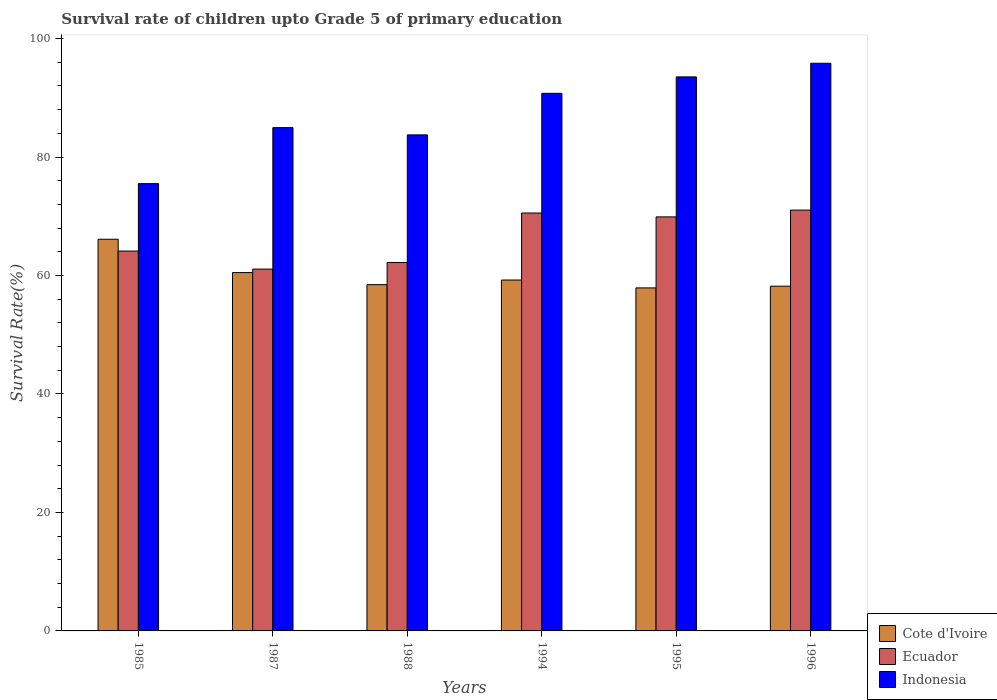How many groups of bars are there?
Your answer should be very brief. 6. How many bars are there on the 5th tick from the left?
Give a very brief answer. 3. How many bars are there on the 6th tick from the right?
Give a very brief answer. 3. What is the label of the 1st group of bars from the left?
Give a very brief answer. 1985. In how many cases, is the number of bars for a given year not equal to the number of legend labels?
Your answer should be very brief. 0. What is the survival rate of children in Cote d'Ivoire in 1996?
Make the answer very short. 58.19. Across all years, what is the maximum survival rate of children in Ecuador?
Offer a very short reply. 71.04. Across all years, what is the minimum survival rate of children in Cote d'Ivoire?
Offer a very short reply. 57.91. In which year was the survival rate of children in Indonesia minimum?
Your answer should be very brief. 1985. What is the total survival rate of children in Cote d'Ivoire in the graph?
Provide a short and direct response. 360.4. What is the difference between the survival rate of children in Cote d'Ivoire in 1985 and that in 1995?
Provide a succinct answer. 8.21. What is the difference between the survival rate of children in Ecuador in 1988 and the survival rate of children in Cote d'Ivoire in 1995?
Make the answer very short. 4.29. What is the average survival rate of children in Ecuador per year?
Your response must be concise. 66.48. In the year 1995, what is the difference between the survival rate of children in Ecuador and survival rate of children in Cote d'Ivoire?
Keep it short and to the point. 11.99. What is the ratio of the survival rate of children in Ecuador in 1994 to that in 1995?
Keep it short and to the point. 1.01. Is the survival rate of children in Ecuador in 1987 less than that in 1988?
Your response must be concise. Yes. What is the difference between the highest and the second highest survival rate of children in Cote d'Ivoire?
Keep it short and to the point. 5.63. What is the difference between the highest and the lowest survival rate of children in Cote d'Ivoire?
Give a very brief answer. 8.21. Is the sum of the survival rate of children in Indonesia in 1985 and 1988 greater than the maximum survival rate of children in Cote d'Ivoire across all years?
Provide a short and direct response. Yes. What does the 1st bar from the left in 1995 represents?
Offer a very short reply. Cote d'Ivoire. What does the 3rd bar from the right in 1988 represents?
Your answer should be compact. Cote d'Ivoire. What is the difference between two consecutive major ticks on the Y-axis?
Keep it short and to the point. 20. Where does the legend appear in the graph?
Ensure brevity in your answer.  Bottom right. How many legend labels are there?
Your response must be concise. 3. How are the legend labels stacked?
Offer a very short reply. Vertical. What is the title of the graph?
Provide a short and direct response. Survival rate of children upto Grade 5 of primary education. What is the label or title of the X-axis?
Ensure brevity in your answer.  Years. What is the label or title of the Y-axis?
Give a very brief answer. Survival Rate(%). What is the Survival Rate(%) of Cote d'Ivoire in 1985?
Your answer should be very brief. 66.12. What is the Survival Rate(%) of Ecuador in 1985?
Give a very brief answer. 64.13. What is the Survival Rate(%) in Indonesia in 1985?
Your answer should be compact. 75.51. What is the Survival Rate(%) of Cote d'Ivoire in 1987?
Provide a succinct answer. 60.49. What is the Survival Rate(%) of Ecuador in 1987?
Provide a short and direct response. 61.08. What is the Survival Rate(%) in Indonesia in 1987?
Make the answer very short. 84.96. What is the Survival Rate(%) in Cote d'Ivoire in 1988?
Make the answer very short. 58.46. What is the Survival Rate(%) of Ecuador in 1988?
Make the answer very short. 62.2. What is the Survival Rate(%) in Indonesia in 1988?
Offer a terse response. 83.74. What is the Survival Rate(%) of Cote d'Ivoire in 1994?
Offer a terse response. 59.23. What is the Survival Rate(%) in Ecuador in 1994?
Give a very brief answer. 70.55. What is the Survival Rate(%) of Indonesia in 1994?
Your answer should be very brief. 90.75. What is the Survival Rate(%) of Cote d'Ivoire in 1995?
Offer a terse response. 57.91. What is the Survival Rate(%) in Ecuador in 1995?
Keep it short and to the point. 69.89. What is the Survival Rate(%) in Indonesia in 1995?
Provide a short and direct response. 93.52. What is the Survival Rate(%) in Cote d'Ivoire in 1996?
Your response must be concise. 58.19. What is the Survival Rate(%) of Ecuador in 1996?
Your answer should be compact. 71.04. What is the Survival Rate(%) of Indonesia in 1996?
Keep it short and to the point. 95.83. Across all years, what is the maximum Survival Rate(%) in Cote d'Ivoire?
Give a very brief answer. 66.12. Across all years, what is the maximum Survival Rate(%) in Ecuador?
Your response must be concise. 71.04. Across all years, what is the maximum Survival Rate(%) of Indonesia?
Your answer should be compact. 95.83. Across all years, what is the minimum Survival Rate(%) of Cote d'Ivoire?
Your answer should be very brief. 57.91. Across all years, what is the minimum Survival Rate(%) of Ecuador?
Your answer should be compact. 61.08. Across all years, what is the minimum Survival Rate(%) in Indonesia?
Your answer should be very brief. 75.51. What is the total Survival Rate(%) in Cote d'Ivoire in the graph?
Your response must be concise. 360.4. What is the total Survival Rate(%) in Ecuador in the graph?
Your answer should be very brief. 398.88. What is the total Survival Rate(%) of Indonesia in the graph?
Your response must be concise. 524.31. What is the difference between the Survival Rate(%) in Cote d'Ivoire in 1985 and that in 1987?
Your response must be concise. 5.63. What is the difference between the Survival Rate(%) in Ecuador in 1985 and that in 1987?
Offer a terse response. 3.04. What is the difference between the Survival Rate(%) of Indonesia in 1985 and that in 1987?
Your answer should be compact. -9.45. What is the difference between the Survival Rate(%) of Cote d'Ivoire in 1985 and that in 1988?
Give a very brief answer. 7.66. What is the difference between the Survival Rate(%) in Ecuador in 1985 and that in 1988?
Make the answer very short. 1.93. What is the difference between the Survival Rate(%) in Indonesia in 1985 and that in 1988?
Offer a very short reply. -8.23. What is the difference between the Survival Rate(%) in Cote d'Ivoire in 1985 and that in 1994?
Offer a very short reply. 6.89. What is the difference between the Survival Rate(%) of Ecuador in 1985 and that in 1994?
Offer a very short reply. -6.42. What is the difference between the Survival Rate(%) of Indonesia in 1985 and that in 1994?
Keep it short and to the point. -15.24. What is the difference between the Survival Rate(%) in Cote d'Ivoire in 1985 and that in 1995?
Offer a very short reply. 8.21. What is the difference between the Survival Rate(%) in Ecuador in 1985 and that in 1995?
Your response must be concise. -5.77. What is the difference between the Survival Rate(%) of Indonesia in 1985 and that in 1995?
Provide a short and direct response. -18.02. What is the difference between the Survival Rate(%) of Cote d'Ivoire in 1985 and that in 1996?
Provide a succinct answer. 7.92. What is the difference between the Survival Rate(%) of Ecuador in 1985 and that in 1996?
Offer a terse response. -6.91. What is the difference between the Survival Rate(%) of Indonesia in 1985 and that in 1996?
Offer a terse response. -20.32. What is the difference between the Survival Rate(%) in Cote d'Ivoire in 1987 and that in 1988?
Provide a short and direct response. 2.03. What is the difference between the Survival Rate(%) in Ecuador in 1987 and that in 1988?
Your response must be concise. -1.11. What is the difference between the Survival Rate(%) in Indonesia in 1987 and that in 1988?
Your answer should be very brief. 1.22. What is the difference between the Survival Rate(%) of Cote d'Ivoire in 1987 and that in 1994?
Offer a terse response. 1.26. What is the difference between the Survival Rate(%) of Ecuador in 1987 and that in 1994?
Your response must be concise. -9.47. What is the difference between the Survival Rate(%) of Indonesia in 1987 and that in 1994?
Provide a succinct answer. -5.79. What is the difference between the Survival Rate(%) in Cote d'Ivoire in 1987 and that in 1995?
Keep it short and to the point. 2.59. What is the difference between the Survival Rate(%) in Ecuador in 1987 and that in 1995?
Offer a very short reply. -8.81. What is the difference between the Survival Rate(%) of Indonesia in 1987 and that in 1995?
Give a very brief answer. -8.56. What is the difference between the Survival Rate(%) of Cote d'Ivoire in 1987 and that in 1996?
Provide a short and direct response. 2.3. What is the difference between the Survival Rate(%) in Ecuador in 1987 and that in 1996?
Provide a succinct answer. -9.96. What is the difference between the Survival Rate(%) of Indonesia in 1987 and that in 1996?
Provide a succinct answer. -10.87. What is the difference between the Survival Rate(%) of Cote d'Ivoire in 1988 and that in 1994?
Offer a very short reply. -0.78. What is the difference between the Survival Rate(%) of Ecuador in 1988 and that in 1994?
Provide a short and direct response. -8.35. What is the difference between the Survival Rate(%) of Indonesia in 1988 and that in 1994?
Offer a very short reply. -7.01. What is the difference between the Survival Rate(%) of Cote d'Ivoire in 1988 and that in 1995?
Offer a terse response. 0.55. What is the difference between the Survival Rate(%) in Ecuador in 1988 and that in 1995?
Make the answer very short. -7.7. What is the difference between the Survival Rate(%) of Indonesia in 1988 and that in 1995?
Make the answer very short. -9.79. What is the difference between the Survival Rate(%) in Cote d'Ivoire in 1988 and that in 1996?
Keep it short and to the point. 0.26. What is the difference between the Survival Rate(%) in Ecuador in 1988 and that in 1996?
Your response must be concise. -8.84. What is the difference between the Survival Rate(%) in Indonesia in 1988 and that in 1996?
Provide a succinct answer. -12.09. What is the difference between the Survival Rate(%) of Cote d'Ivoire in 1994 and that in 1995?
Your answer should be compact. 1.33. What is the difference between the Survival Rate(%) of Ecuador in 1994 and that in 1995?
Offer a terse response. 0.66. What is the difference between the Survival Rate(%) of Indonesia in 1994 and that in 1995?
Offer a very short reply. -2.77. What is the difference between the Survival Rate(%) of Cote d'Ivoire in 1994 and that in 1996?
Provide a succinct answer. 1.04. What is the difference between the Survival Rate(%) of Ecuador in 1994 and that in 1996?
Ensure brevity in your answer.  -0.49. What is the difference between the Survival Rate(%) of Indonesia in 1994 and that in 1996?
Your answer should be compact. -5.08. What is the difference between the Survival Rate(%) in Cote d'Ivoire in 1995 and that in 1996?
Make the answer very short. -0.29. What is the difference between the Survival Rate(%) in Ecuador in 1995 and that in 1996?
Make the answer very short. -1.14. What is the difference between the Survival Rate(%) in Indonesia in 1995 and that in 1996?
Your answer should be compact. -2.3. What is the difference between the Survival Rate(%) of Cote d'Ivoire in 1985 and the Survival Rate(%) of Ecuador in 1987?
Give a very brief answer. 5.04. What is the difference between the Survival Rate(%) of Cote d'Ivoire in 1985 and the Survival Rate(%) of Indonesia in 1987?
Offer a very short reply. -18.84. What is the difference between the Survival Rate(%) of Ecuador in 1985 and the Survival Rate(%) of Indonesia in 1987?
Provide a succinct answer. -20.84. What is the difference between the Survival Rate(%) in Cote d'Ivoire in 1985 and the Survival Rate(%) in Ecuador in 1988?
Your response must be concise. 3.92. What is the difference between the Survival Rate(%) of Cote d'Ivoire in 1985 and the Survival Rate(%) of Indonesia in 1988?
Make the answer very short. -17.62. What is the difference between the Survival Rate(%) in Ecuador in 1985 and the Survival Rate(%) in Indonesia in 1988?
Make the answer very short. -19.61. What is the difference between the Survival Rate(%) in Cote d'Ivoire in 1985 and the Survival Rate(%) in Ecuador in 1994?
Your answer should be very brief. -4.43. What is the difference between the Survival Rate(%) in Cote d'Ivoire in 1985 and the Survival Rate(%) in Indonesia in 1994?
Offer a terse response. -24.63. What is the difference between the Survival Rate(%) of Ecuador in 1985 and the Survival Rate(%) of Indonesia in 1994?
Provide a succinct answer. -26.63. What is the difference between the Survival Rate(%) of Cote d'Ivoire in 1985 and the Survival Rate(%) of Ecuador in 1995?
Ensure brevity in your answer.  -3.77. What is the difference between the Survival Rate(%) in Cote d'Ivoire in 1985 and the Survival Rate(%) in Indonesia in 1995?
Ensure brevity in your answer.  -27.41. What is the difference between the Survival Rate(%) in Ecuador in 1985 and the Survival Rate(%) in Indonesia in 1995?
Provide a short and direct response. -29.4. What is the difference between the Survival Rate(%) of Cote d'Ivoire in 1985 and the Survival Rate(%) of Ecuador in 1996?
Offer a terse response. -4.92. What is the difference between the Survival Rate(%) of Cote d'Ivoire in 1985 and the Survival Rate(%) of Indonesia in 1996?
Offer a very short reply. -29.71. What is the difference between the Survival Rate(%) of Ecuador in 1985 and the Survival Rate(%) of Indonesia in 1996?
Your answer should be compact. -31.7. What is the difference between the Survival Rate(%) in Cote d'Ivoire in 1987 and the Survival Rate(%) in Ecuador in 1988?
Your answer should be very brief. -1.7. What is the difference between the Survival Rate(%) of Cote d'Ivoire in 1987 and the Survival Rate(%) of Indonesia in 1988?
Offer a terse response. -23.24. What is the difference between the Survival Rate(%) in Ecuador in 1987 and the Survival Rate(%) in Indonesia in 1988?
Offer a terse response. -22.65. What is the difference between the Survival Rate(%) of Cote d'Ivoire in 1987 and the Survival Rate(%) of Ecuador in 1994?
Provide a succinct answer. -10.06. What is the difference between the Survival Rate(%) in Cote d'Ivoire in 1987 and the Survival Rate(%) in Indonesia in 1994?
Your answer should be very brief. -30.26. What is the difference between the Survival Rate(%) of Ecuador in 1987 and the Survival Rate(%) of Indonesia in 1994?
Your answer should be very brief. -29.67. What is the difference between the Survival Rate(%) in Cote d'Ivoire in 1987 and the Survival Rate(%) in Ecuador in 1995?
Give a very brief answer. -9.4. What is the difference between the Survival Rate(%) in Cote d'Ivoire in 1987 and the Survival Rate(%) in Indonesia in 1995?
Your response must be concise. -33.03. What is the difference between the Survival Rate(%) in Ecuador in 1987 and the Survival Rate(%) in Indonesia in 1995?
Your answer should be compact. -32.44. What is the difference between the Survival Rate(%) in Cote d'Ivoire in 1987 and the Survival Rate(%) in Ecuador in 1996?
Ensure brevity in your answer.  -10.55. What is the difference between the Survival Rate(%) in Cote d'Ivoire in 1987 and the Survival Rate(%) in Indonesia in 1996?
Give a very brief answer. -35.33. What is the difference between the Survival Rate(%) in Ecuador in 1987 and the Survival Rate(%) in Indonesia in 1996?
Keep it short and to the point. -34.74. What is the difference between the Survival Rate(%) of Cote d'Ivoire in 1988 and the Survival Rate(%) of Ecuador in 1994?
Offer a terse response. -12.09. What is the difference between the Survival Rate(%) of Cote d'Ivoire in 1988 and the Survival Rate(%) of Indonesia in 1994?
Offer a very short reply. -32.29. What is the difference between the Survival Rate(%) in Ecuador in 1988 and the Survival Rate(%) in Indonesia in 1994?
Provide a short and direct response. -28.56. What is the difference between the Survival Rate(%) in Cote d'Ivoire in 1988 and the Survival Rate(%) in Ecuador in 1995?
Ensure brevity in your answer.  -11.43. What is the difference between the Survival Rate(%) in Cote d'Ivoire in 1988 and the Survival Rate(%) in Indonesia in 1995?
Ensure brevity in your answer.  -35.07. What is the difference between the Survival Rate(%) in Ecuador in 1988 and the Survival Rate(%) in Indonesia in 1995?
Your answer should be very brief. -31.33. What is the difference between the Survival Rate(%) in Cote d'Ivoire in 1988 and the Survival Rate(%) in Ecuador in 1996?
Offer a very short reply. -12.58. What is the difference between the Survival Rate(%) in Cote d'Ivoire in 1988 and the Survival Rate(%) in Indonesia in 1996?
Your response must be concise. -37.37. What is the difference between the Survival Rate(%) in Ecuador in 1988 and the Survival Rate(%) in Indonesia in 1996?
Your answer should be compact. -33.63. What is the difference between the Survival Rate(%) of Cote d'Ivoire in 1994 and the Survival Rate(%) of Ecuador in 1995?
Keep it short and to the point. -10.66. What is the difference between the Survival Rate(%) in Cote d'Ivoire in 1994 and the Survival Rate(%) in Indonesia in 1995?
Offer a very short reply. -34.29. What is the difference between the Survival Rate(%) of Ecuador in 1994 and the Survival Rate(%) of Indonesia in 1995?
Provide a succinct answer. -22.98. What is the difference between the Survival Rate(%) in Cote d'Ivoire in 1994 and the Survival Rate(%) in Ecuador in 1996?
Your response must be concise. -11.8. What is the difference between the Survival Rate(%) in Cote d'Ivoire in 1994 and the Survival Rate(%) in Indonesia in 1996?
Your answer should be compact. -36.59. What is the difference between the Survival Rate(%) of Ecuador in 1994 and the Survival Rate(%) of Indonesia in 1996?
Your answer should be compact. -25.28. What is the difference between the Survival Rate(%) in Cote d'Ivoire in 1995 and the Survival Rate(%) in Ecuador in 1996?
Keep it short and to the point. -13.13. What is the difference between the Survival Rate(%) of Cote d'Ivoire in 1995 and the Survival Rate(%) of Indonesia in 1996?
Give a very brief answer. -37.92. What is the difference between the Survival Rate(%) of Ecuador in 1995 and the Survival Rate(%) of Indonesia in 1996?
Offer a terse response. -25.93. What is the average Survival Rate(%) in Cote d'Ivoire per year?
Give a very brief answer. 60.07. What is the average Survival Rate(%) of Ecuador per year?
Your answer should be compact. 66.48. What is the average Survival Rate(%) of Indonesia per year?
Your response must be concise. 87.38. In the year 1985, what is the difference between the Survival Rate(%) of Cote d'Ivoire and Survival Rate(%) of Ecuador?
Your answer should be compact. 1.99. In the year 1985, what is the difference between the Survival Rate(%) of Cote d'Ivoire and Survival Rate(%) of Indonesia?
Provide a short and direct response. -9.39. In the year 1985, what is the difference between the Survival Rate(%) in Ecuador and Survival Rate(%) in Indonesia?
Offer a very short reply. -11.38. In the year 1987, what is the difference between the Survival Rate(%) in Cote d'Ivoire and Survival Rate(%) in Ecuador?
Provide a short and direct response. -0.59. In the year 1987, what is the difference between the Survival Rate(%) in Cote d'Ivoire and Survival Rate(%) in Indonesia?
Offer a very short reply. -24.47. In the year 1987, what is the difference between the Survival Rate(%) of Ecuador and Survival Rate(%) of Indonesia?
Provide a succinct answer. -23.88. In the year 1988, what is the difference between the Survival Rate(%) of Cote d'Ivoire and Survival Rate(%) of Ecuador?
Your answer should be compact. -3.74. In the year 1988, what is the difference between the Survival Rate(%) in Cote d'Ivoire and Survival Rate(%) in Indonesia?
Your response must be concise. -25.28. In the year 1988, what is the difference between the Survival Rate(%) of Ecuador and Survival Rate(%) of Indonesia?
Offer a very short reply. -21.54. In the year 1994, what is the difference between the Survival Rate(%) of Cote d'Ivoire and Survival Rate(%) of Ecuador?
Give a very brief answer. -11.31. In the year 1994, what is the difference between the Survival Rate(%) of Cote d'Ivoire and Survival Rate(%) of Indonesia?
Your answer should be compact. -31.52. In the year 1994, what is the difference between the Survival Rate(%) in Ecuador and Survival Rate(%) in Indonesia?
Offer a terse response. -20.2. In the year 1995, what is the difference between the Survival Rate(%) of Cote d'Ivoire and Survival Rate(%) of Ecuador?
Your response must be concise. -11.99. In the year 1995, what is the difference between the Survival Rate(%) in Cote d'Ivoire and Survival Rate(%) in Indonesia?
Provide a succinct answer. -35.62. In the year 1995, what is the difference between the Survival Rate(%) of Ecuador and Survival Rate(%) of Indonesia?
Your answer should be compact. -23.63. In the year 1996, what is the difference between the Survival Rate(%) in Cote d'Ivoire and Survival Rate(%) in Ecuador?
Offer a very short reply. -12.84. In the year 1996, what is the difference between the Survival Rate(%) of Cote d'Ivoire and Survival Rate(%) of Indonesia?
Provide a short and direct response. -37.63. In the year 1996, what is the difference between the Survival Rate(%) in Ecuador and Survival Rate(%) in Indonesia?
Make the answer very short. -24.79. What is the ratio of the Survival Rate(%) in Cote d'Ivoire in 1985 to that in 1987?
Offer a very short reply. 1.09. What is the ratio of the Survival Rate(%) of Ecuador in 1985 to that in 1987?
Give a very brief answer. 1.05. What is the ratio of the Survival Rate(%) in Indonesia in 1985 to that in 1987?
Offer a terse response. 0.89. What is the ratio of the Survival Rate(%) in Cote d'Ivoire in 1985 to that in 1988?
Provide a short and direct response. 1.13. What is the ratio of the Survival Rate(%) of Ecuador in 1985 to that in 1988?
Provide a short and direct response. 1.03. What is the ratio of the Survival Rate(%) in Indonesia in 1985 to that in 1988?
Provide a short and direct response. 0.9. What is the ratio of the Survival Rate(%) of Cote d'Ivoire in 1985 to that in 1994?
Your response must be concise. 1.12. What is the ratio of the Survival Rate(%) in Ecuador in 1985 to that in 1994?
Your answer should be very brief. 0.91. What is the ratio of the Survival Rate(%) of Indonesia in 1985 to that in 1994?
Offer a terse response. 0.83. What is the ratio of the Survival Rate(%) of Cote d'Ivoire in 1985 to that in 1995?
Give a very brief answer. 1.14. What is the ratio of the Survival Rate(%) of Ecuador in 1985 to that in 1995?
Provide a short and direct response. 0.92. What is the ratio of the Survival Rate(%) of Indonesia in 1985 to that in 1995?
Your response must be concise. 0.81. What is the ratio of the Survival Rate(%) of Cote d'Ivoire in 1985 to that in 1996?
Provide a succinct answer. 1.14. What is the ratio of the Survival Rate(%) of Ecuador in 1985 to that in 1996?
Give a very brief answer. 0.9. What is the ratio of the Survival Rate(%) of Indonesia in 1985 to that in 1996?
Your answer should be very brief. 0.79. What is the ratio of the Survival Rate(%) in Cote d'Ivoire in 1987 to that in 1988?
Your answer should be compact. 1.03. What is the ratio of the Survival Rate(%) of Ecuador in 1987 to that in 1988?
Offer a very short reply. 0.98. What is the ratio of the Survival Rate(%) of Indonesia in 1987 to that in 1988?
Your answer should be compact. 1.01. What is the ratio of the Survival Rate(%) in Cote d'Ivoire in 1987 to that in 1994?
Provide a short and direct response. 1.02. What is the ratio of the Survival Rate(%) in Ecuador in 1987 to that in 1994?
Make the answer very short. 0.87. What is the ratio of the Survival Rate(%) of Indonesia in 1987 to that in 1994?
Your answer should be compact. 0.94. What is the ratio of the Survival Rate(%) of Cote d'Ivoire in 1987 to that in 1995?
Your answer should be very brief. 1.04. What is the ratio of the Survival Rate(%) of Ecuador in 1987 to that in 1995?
Your response must be concise. 0.87. What is the ratio of the Survival Rate(%) in Indonesia in 1987 to that in 1995?
Offer a terse response. 0.91. What is the ratio of the Survival Rate(%) of Cote d'Ivoire in 1987 to that in 1996?
Make the answer very short. 1.04. What is the ratio of the Survival Rate(%) in Ecuador in 1987 to that in 1996?
Make the answer very short. 0.86. What is the ratio of the Survival Rate(%) in Indonesia in 1987 to that in 1996?
Keep it short and to the point. 0.89. What is the ratio of the Survival Rate(%) of Cote d'Ivoire in 1988 to that in 1994?
Keep it short and to the point. 0.99. What is the ratio of the Survival Rate(%) in Ecuador in 1988 to that in 1994?
Ensure brevity in your answer.  0.88. What is the ratio of the Survival Rate(%) of Indonesia in 1988 to that in 1994?
Your answer should be compact. 0.92. What is the ratio of the Survival Rate(%) in Cote d'Ivoire in 1988 to that in 1995?
Your response must be concise. 1.01. What is the ratio of the Survival Rate(%) in Ecuador in 1988 to that in 1995?
Provide a short and direct response. 0.89. What is the ratio of the Survival Rate(%) of Indonesia in 1988 to that in 1995?
Keep it short and to the point. 0.9. What is the ratio of the Survival Rate(%) in Ecuador in 1988 to that in 1996?
Provide a succinct answer. 0.88. What is the ratio of the Survival Rate(%) in Indonesia in 1988 to that in 1996?
Offer a very short reply. 0.87. What is the ratio of the Survival Rate(%) of Cote d'Ivoire in 1994 to that in 1995?
Give a very brief answer. 1.02. What is the ratio of the Survival Rate(%) in Ecuador in 1994 to that in 1995?
Your answer should be very brief. 1.01. What is the ratio of the Survival Rate(%) of Indonesia in 1994 to that in 1995?
Provide a succinct answer. 0.97. What is the ratio of the Survival Rate(%) of Cote d'Ivoire in 1994 to that in 1996?
Ensure brevity in your answer.  1.02. What is the ratio of the Survival Rate(%) in Ecuador in 1994 to that in 1996?
Give a very brief answer. 0.99. What is the ratio of the Survival Rate(%) in Indonesia in 1994 to that in 1996?
Make the answer very short. 0.95. What is the ratio of the Survival Rate(%) of Cote d'Ivoire in 1995 to that in 1996?
Give a very brief answer. 0.99. What is the ratio of the Survival Rate(%) in Ecuador in 1995 to that in 1996?
Make the answer very short. 0.98. What is the difference between the highest and the second highest Survival Rate(%) in Cote d'Ivoire?
Provide a succinct answer. 5.63. What is the difference between the highest and the second highest Survival Rate(%) in Ecuador?
Offer a terse response. 0.49. What is the difference between the highest and the second highest Survival Rate(%) in Indonesia?
Your response must be concise. 2.3. What is the difference between the highest and the lowest Survival Rate(%) in Cote d'Ivoire?
Your answer should be compact. 8.21. What is the difference between the highest and the lowest Survival Rate(%) of Ecuador?
Give a very brief answer. 9.96. What is the difference between the highest and the lowest Survival Rate(%) in Indonesia?
Your answer should be very brief. 20.32. 